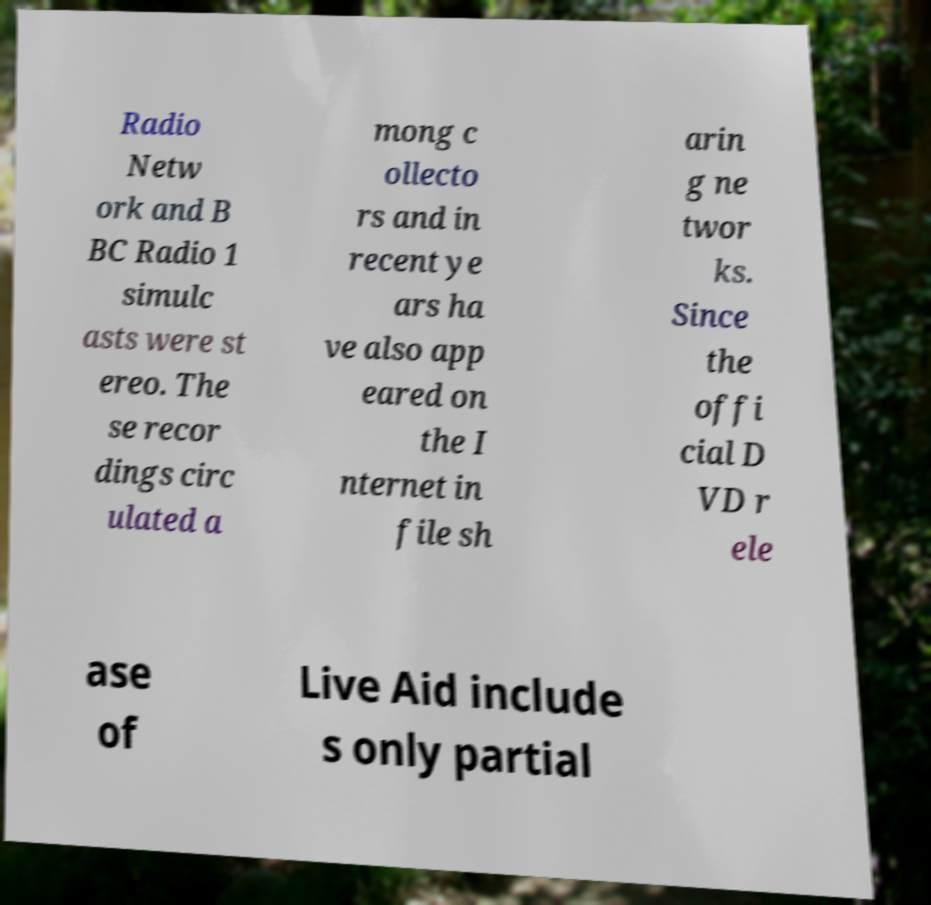For documentation purposes, I need the text within this image transcribed. Could you provide that? Radio Netw ork and B BC Radio 1 simulc asts were st ereo. The se recor dings circ ulated a mong c ollecto rs and in recent ye ars ha ve also app eared on the I nternet in file sh arin g ne twor ks. Since the offi cial D VD r ele ase of Live Aid include s only partial 